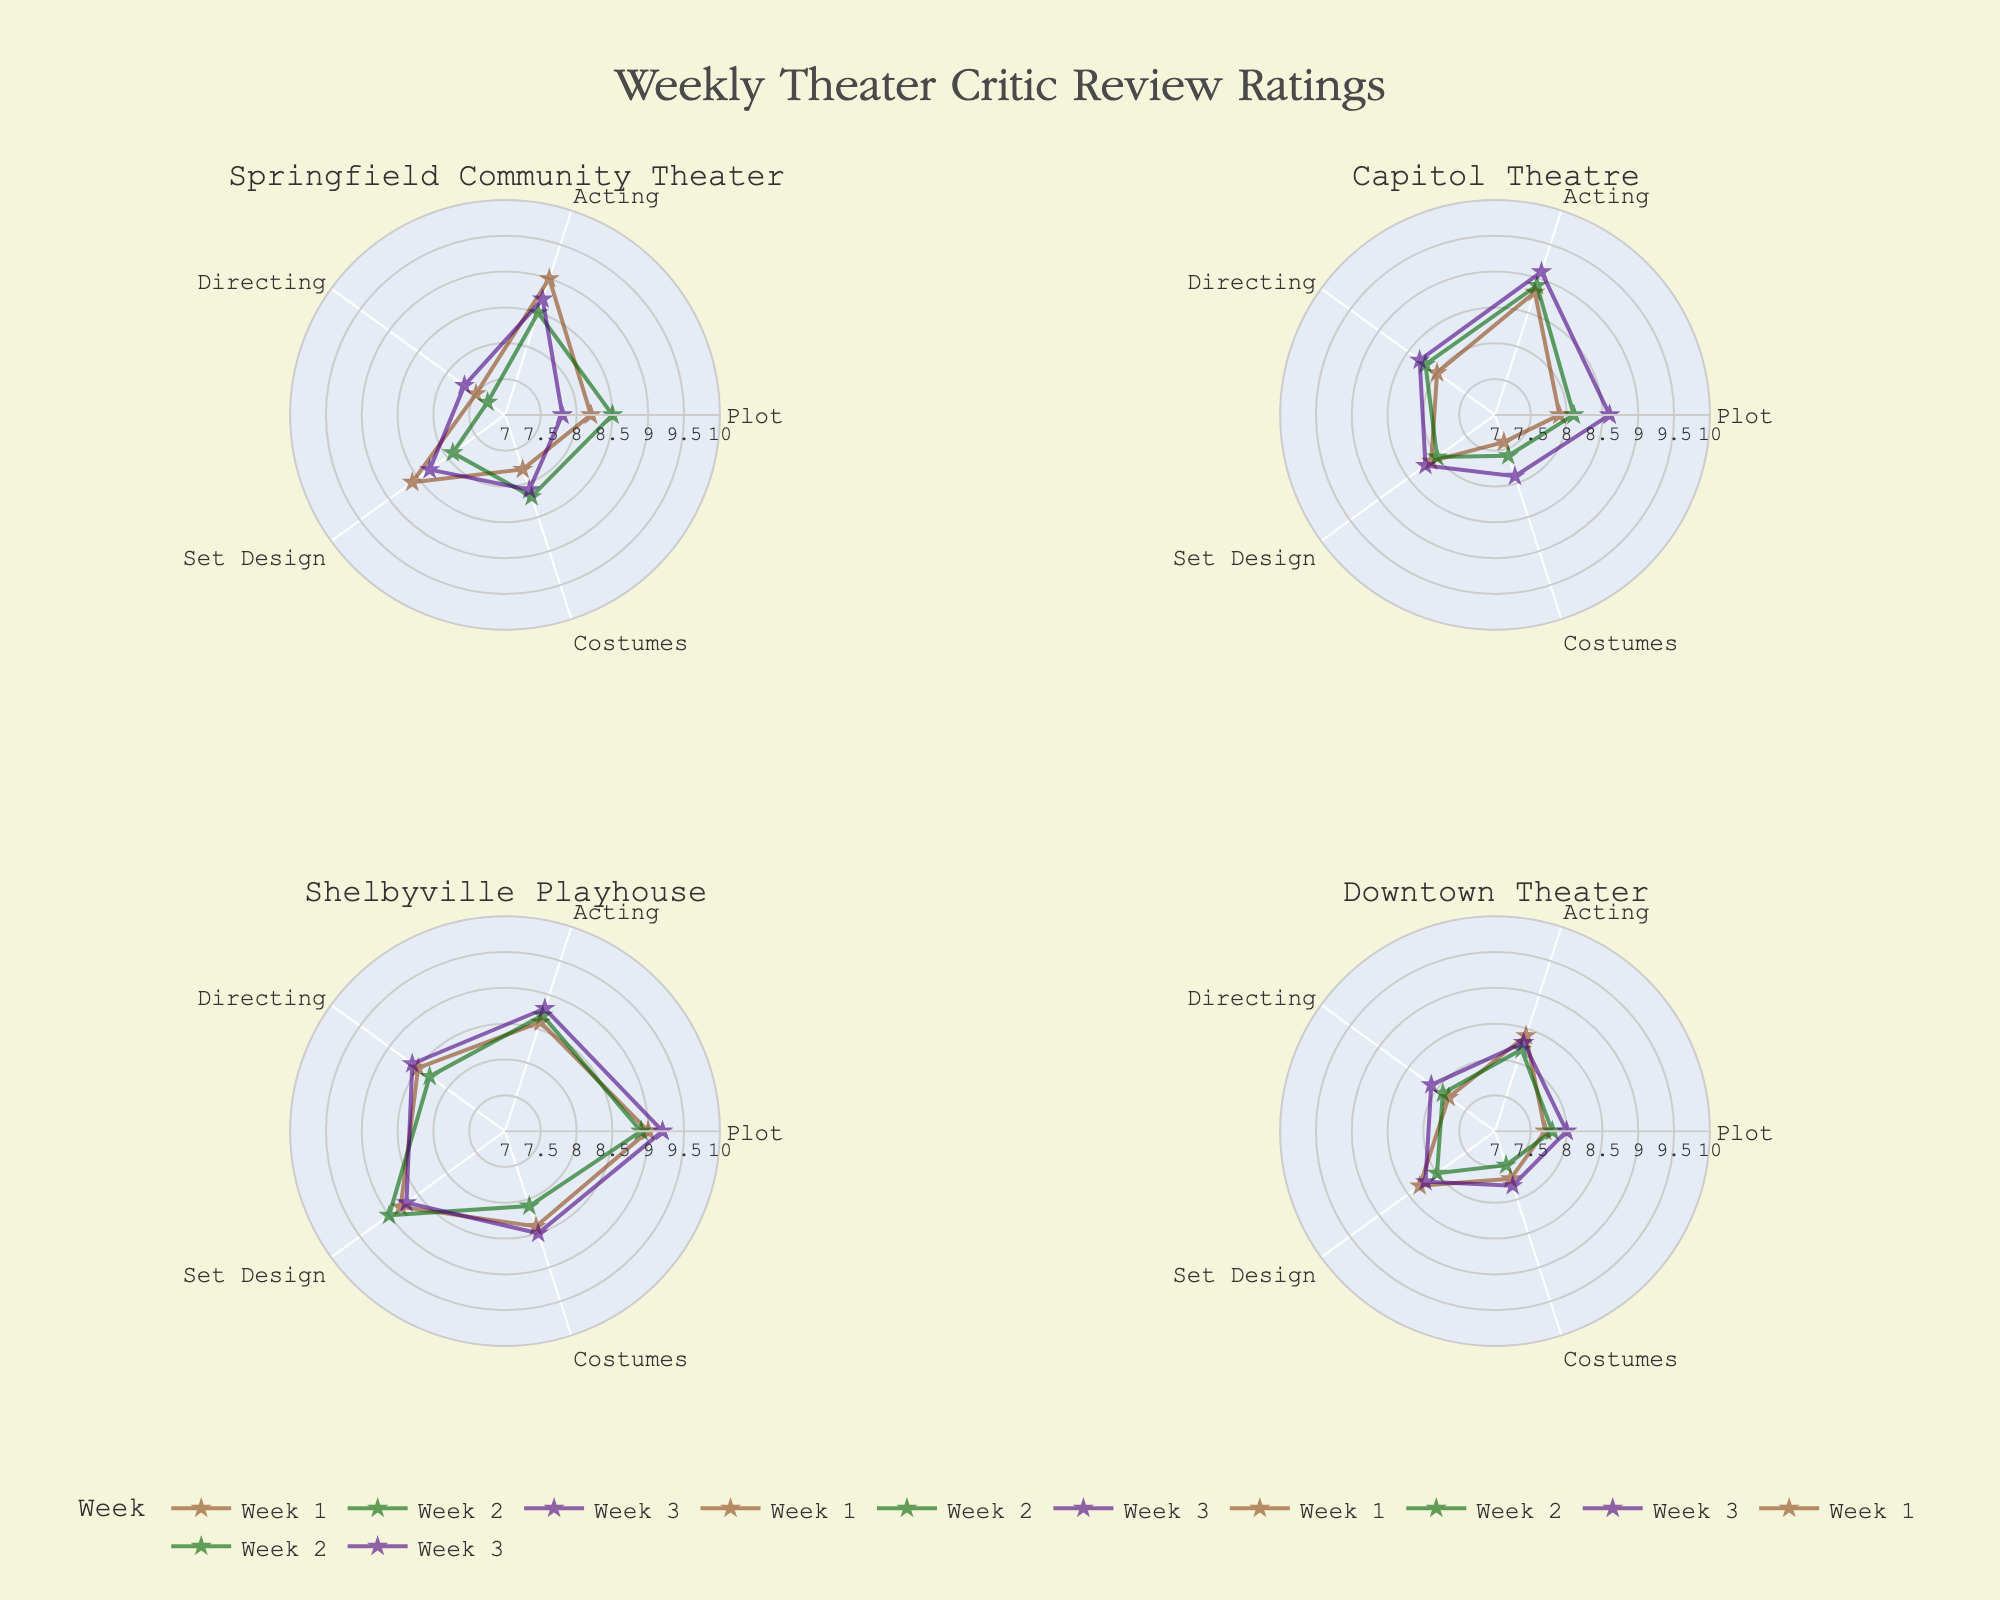what is the title of the plot? The title is located at the top center of the figure and provides a summary of what's being represented in the chart.
Answer: Weekly Theater Critic Review Ratings how many theaters are compared in the figure? By observing the subplot titles, we see the names of the theaters.
Answer: 4 what color is used to represent Week 3? By looking at the legend and noting which color corresponds to Week 3.
Answer: Indigo which theater had the highest rating for Plot in Week 3? Comparing the Plot values in Week 3 among the four theaters. Shelbyville Playhouse has a rating of 9.2.
Answer: Shelbyville Playhouse which category has the lowest rating for Capitol Theatre in Week 2? Observing Capitol Theatre's subplot, notice the point closest to the center for Week 2.
Answer: Costumes compare the average rating of Week 2 Acting for Capitol Theatre and Springfield Community Theater, which is higher? Calculate the average for Week 2 Acting ratings of both theaters: Capitol Theatre (8.9) and Springfield Community Theater (8.5); compare these values.
Answer: Capitol Theatre how did the Set Design ratings for Shelbyville Playhouse change from Week 1 to Week 2? Look at the points for Set Design in Shelbyville Playhouse subplot for both weeks. Week 1 (8.8) and Week 2 (9.0). Calculate the difference 9.0 - 8.8 = 0.2.
Answer: Increased by 0.2 for Downtown Theater in Week 3, which category saw the highest rating? Find the highest point for Downtown Theater Week 3 and note the category. Set Design and Directing are at the highest point (8.2).
Answer: Set Design, Directing what is the range of the radial axis displayed in the plot? Observing the polar plots, the range is the minimum and maximum values presented on the radial axis.
Answer: 7 to 10 